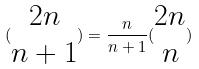<formula> <loc_0><loc_0><loc_500><loc_500>( \begin{matrix} 2 n \\ n + 1 \end{matrix} ) = \frac { n } { n + 1 } ( \begin{matrix} 2 n \\ n \end{matrix} )</formula> 